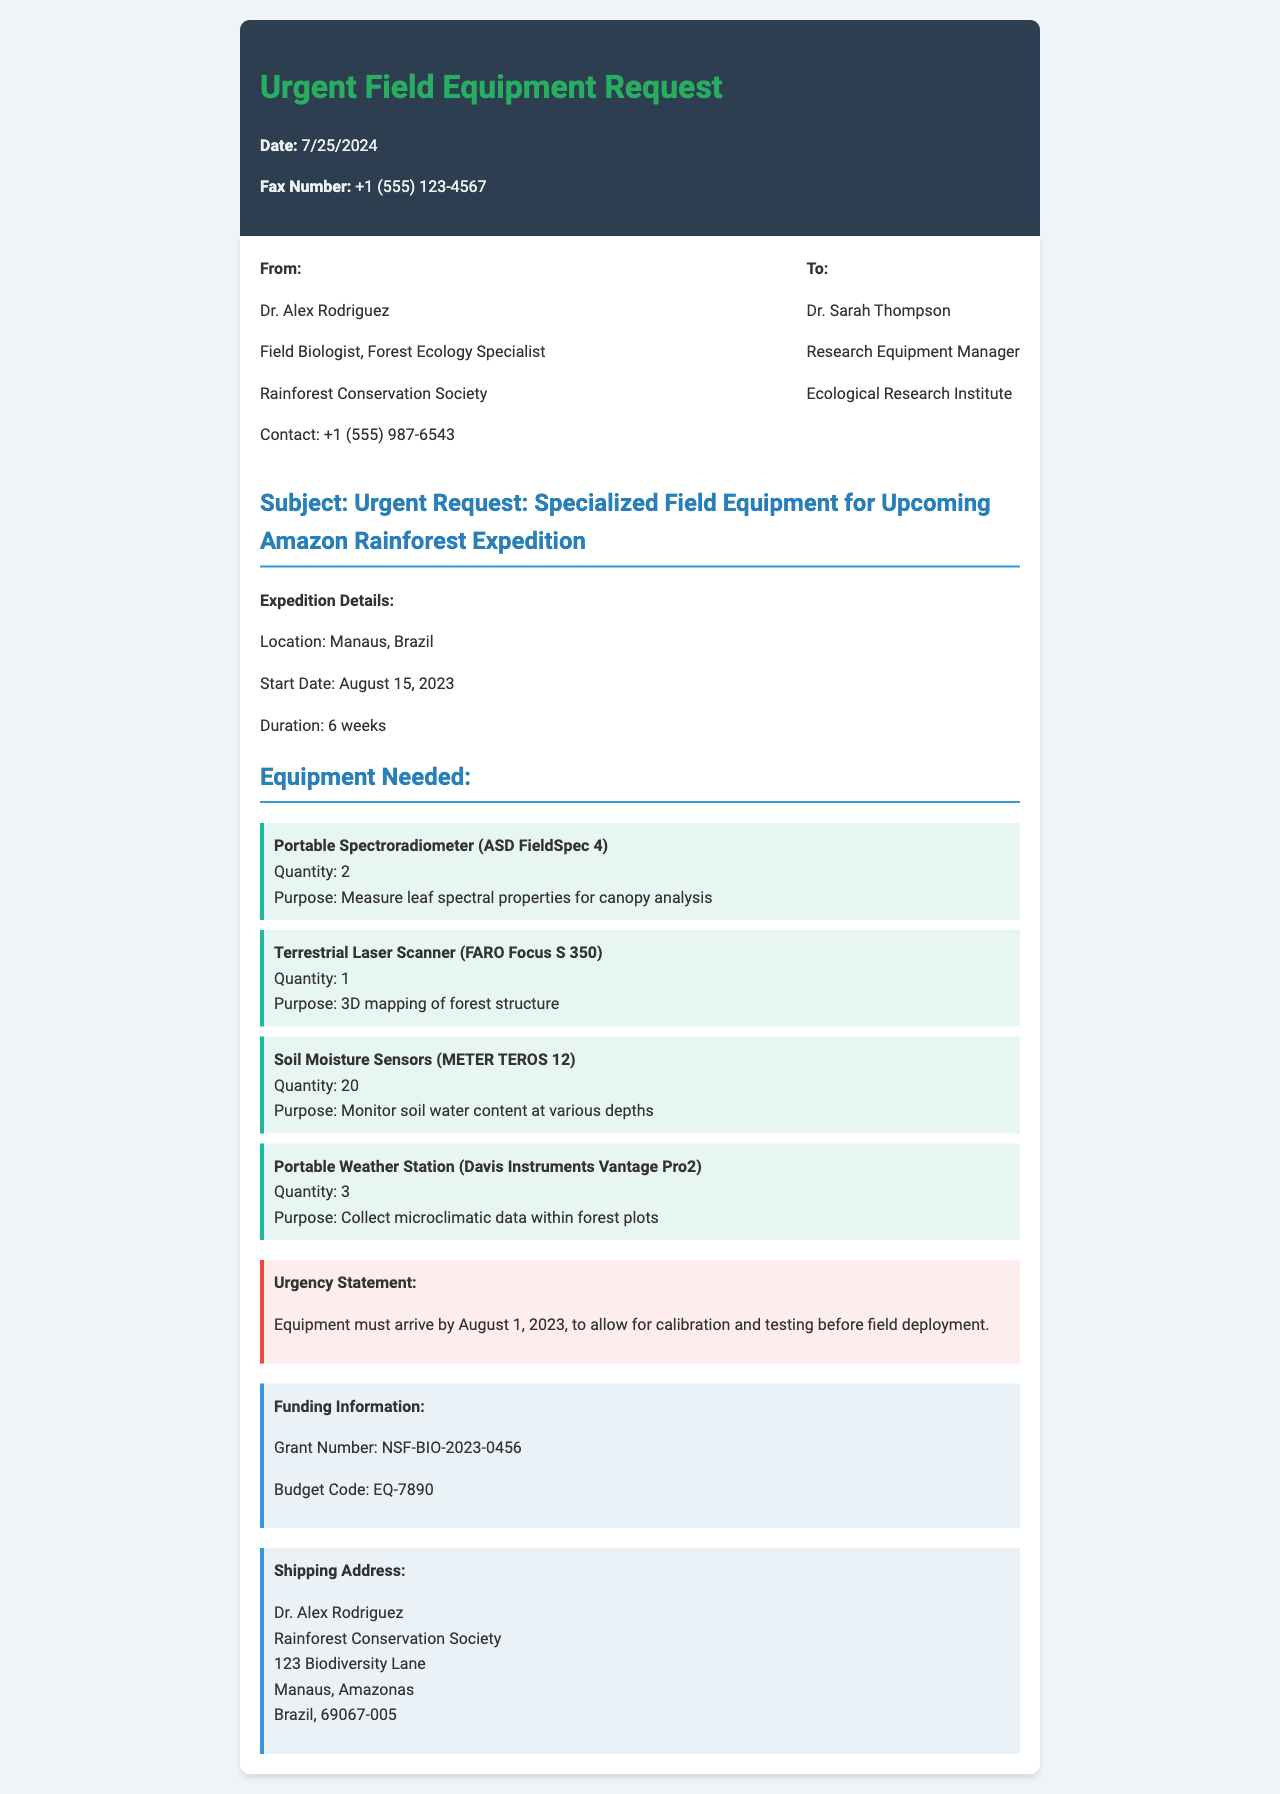what is the name of the sender? The name of the sender is mentioned at the beginning of the fax, which is Dr. Alex Rodriguez.
Answer: Dr. Alex Rodriguez what is the location of the expedition? The location of the expedition is stated in the document as Manaus, Brazil.
Answer: Manaus, Brazil how many Portable Spectroradiometers are needed? The quantity of Portable Spectroradiometers required is 2, as listed in the equipment section.
Answer: 2 when is the equipment required to arrive? The urgency statement specifies that equipment must arrive by August 1, 2023.
Answer: August 1, 2023 what is the purpose of the Soil Moisture Sensors? The purpose of the Soil Moisture Sensors is explained in the equipment section, where it states that they are for monitoring soil water content at various depths.
Answer: Monitor soil water content at various depths who is the recipient of this fax? The recipient of the fax is listed in the sender info section, which mentions Dr. Sarah Thompson.
Answer: Dr. Sarah Thompson how long will the expedition last? The duration of the expedition is mentioned, which is 6 weeks.
Answer: 6 weeks what grant number is provided for funding? The funding information includes a specific Grant Number, which is NSF-BIO-2023-0456.
Answer: NSF-BIO-2023-0456 what is the shipping address state? The shipping address includes the location in Brazil, which is Amazonas.
Answer: Amazonas 